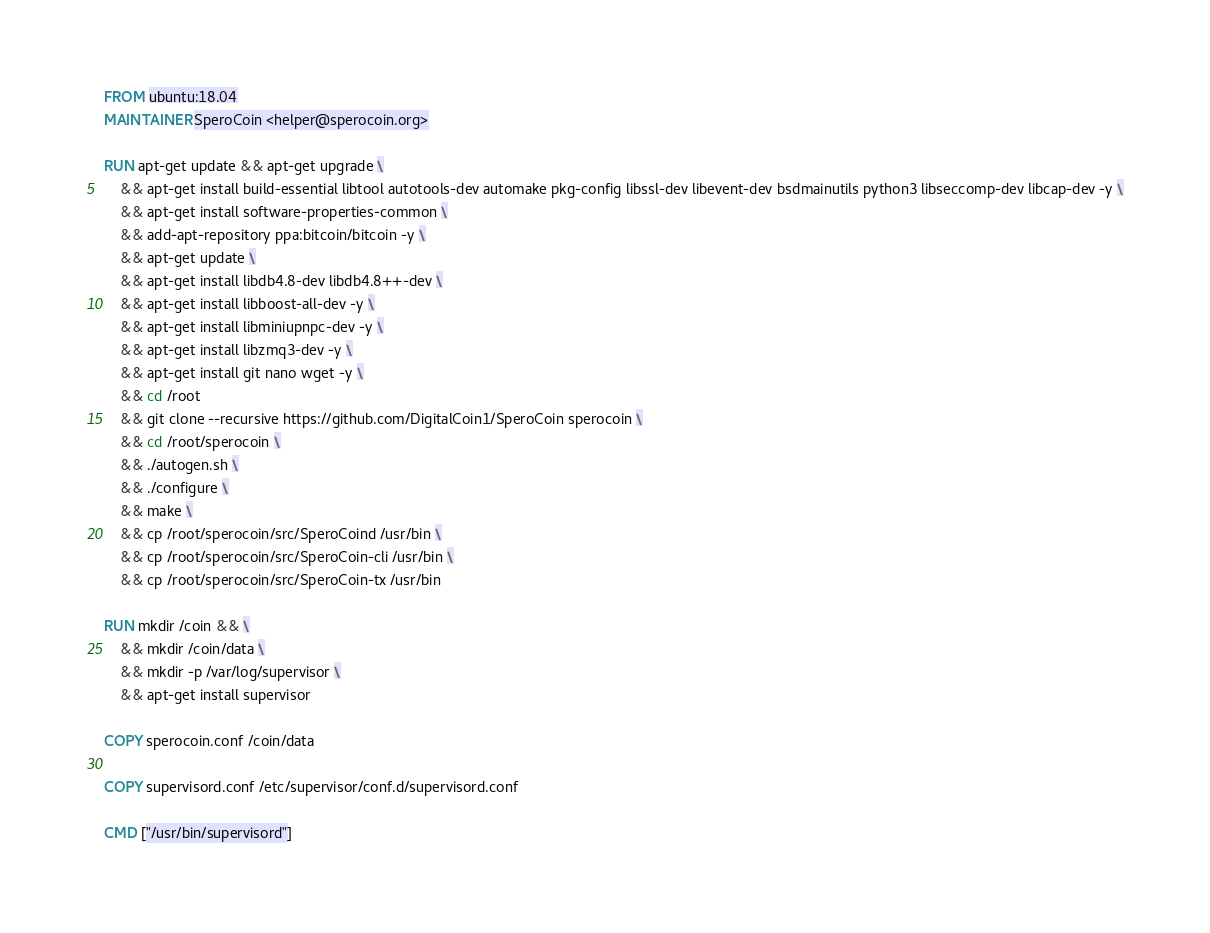Convert code to text. <code><loc_0><loc_0><loc_500><loc_500><_Dockerfile_>FROM ubuntu:18.04
MAINTAINER SperoCoin <helper@sperocoin.org>

RUN apt-get update && apt-get upgrade \
	&& apt-get install build-essential libtool autotools-dev automake pkg-config libssl-dev libevent-dev bsdmainutils python3 libseccomp-dev libcap-dev -y \
	&& apt-get install software-properties-common \
	&& add-apt-repository ppa:bitcoin/bitcoin -y \
	&& apt-get update \
	&& apt-get install libdb4.8-dev libdb4.8++-dev \
	&& apt-get install libboost-all-dev -y \
	&& apt-get install libminiupnpc-dev -y \
	&& apt-get install libzmq3-dev -y \
	&& apt-get install git nano wget -y \
	&& cd /root
	&& git clone --recursive https://github.com/DigitalCoin1/SperoCoin sperocoin \
	&& cd /root/sperocoin \
	&& ./autogen.sh \
	&& ./configure \
	&& make \
	&& cp /root/sperocoin/src/SperoCoind /usr/bin \
	&& cp /root/sperocoin/src/SperoCoin-cli /usr/bin \
	&& cp /root/sperocoin/src/SperoCoin-tx /usr/bin

RUN mkdir /coin && \
	&& mkdir /coin/data \
	&& mkdir -p /var/log/supervisor \
	&& apt-get install supervisor

COPY sperocoin.conf /coin/data

COPY supervisord.conf /etc/supervisor/conf.d/supervisord.conf

CMD ["/usr/bin/supervisord"]</code> 